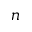Convert formula to latex. <formula><loc_0><loc_0><loc_500><loc_500>n</formula> 